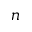Convert formula to latex. <formula><loc_0><loc_0><loc_500><loc_500>n</formula> 